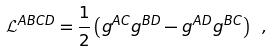<formula> <loc_0><loc_0><loc_500><loc_500>\mathcal { L } ^ { A B C D } = \frac { 1 } { 2 } \left ( g ^ { A C } g ^ { B D } - g ^ { A D } g ^ { B C } \right ) \ ,</formula> 